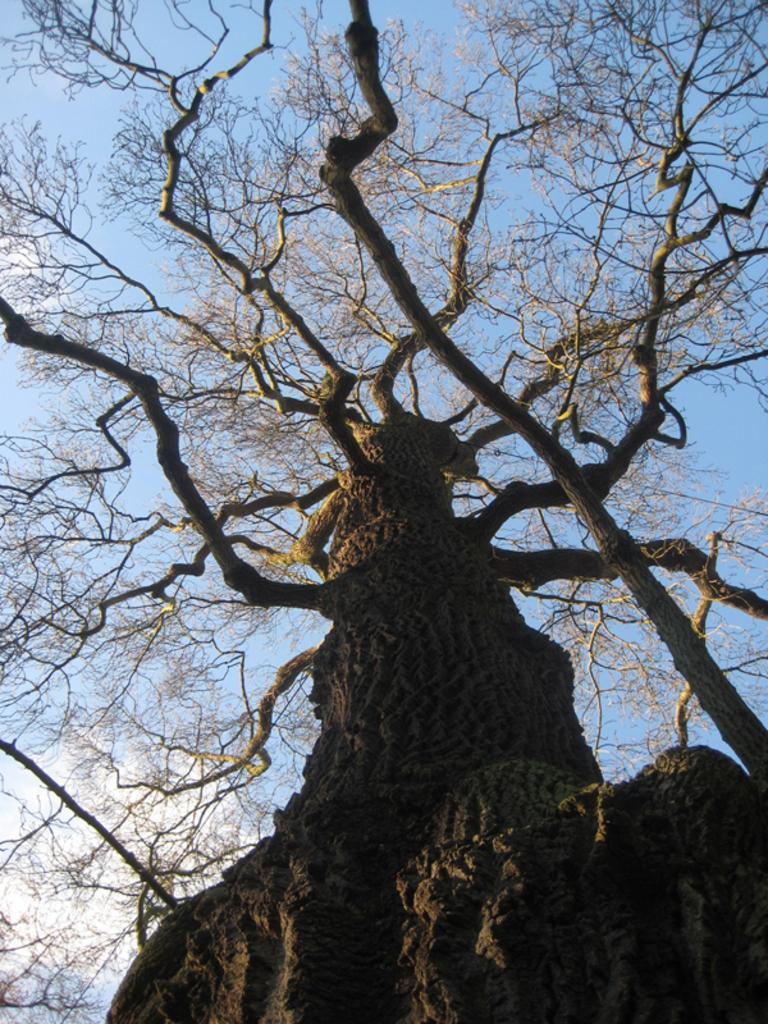In one or two sentences, can you explain what this image depicts? In this image I can see few dried trees. In the background the sky is in blue and white color. 